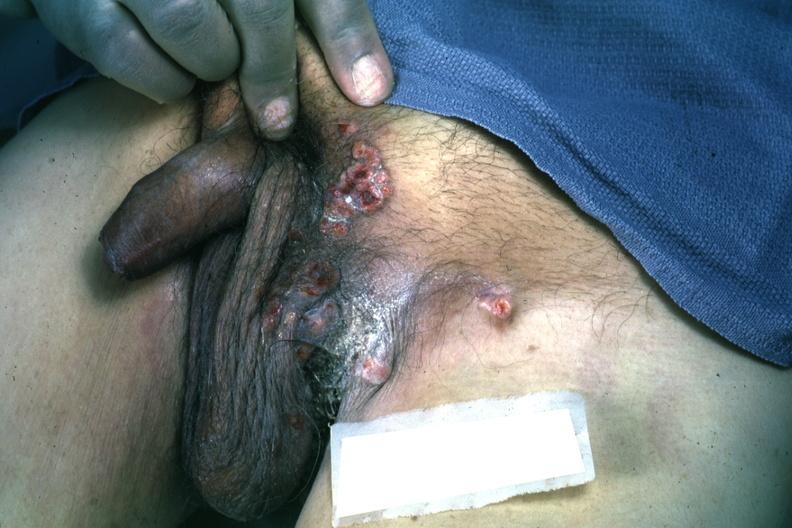s inguinal area present?
Answer the question using a single word or phrase. Yes 